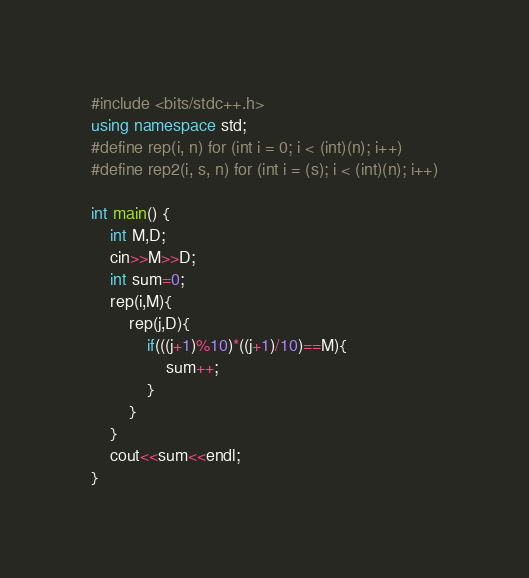Convert code to text. <code><loc_0><loc_0><loc_500><loc_500><_C++_>#include <bits/stdc++.h>
using namespace std;
#define rep(i, n) for (int i = 0; i < (int)(n); i++)
#define rep2(i, s, n) for (int i = (s); i < (int)(n); i++)

int main() {
    int M,D;
    cin>>M>>D;
    int sum=0;
    rep(i,M){
        rep(j,D){
            if(((j+1)%10)*((j+1)/10)==M){
                sum++;
            }
        }
    }
    cout<<sum<<endl;
}</code> 